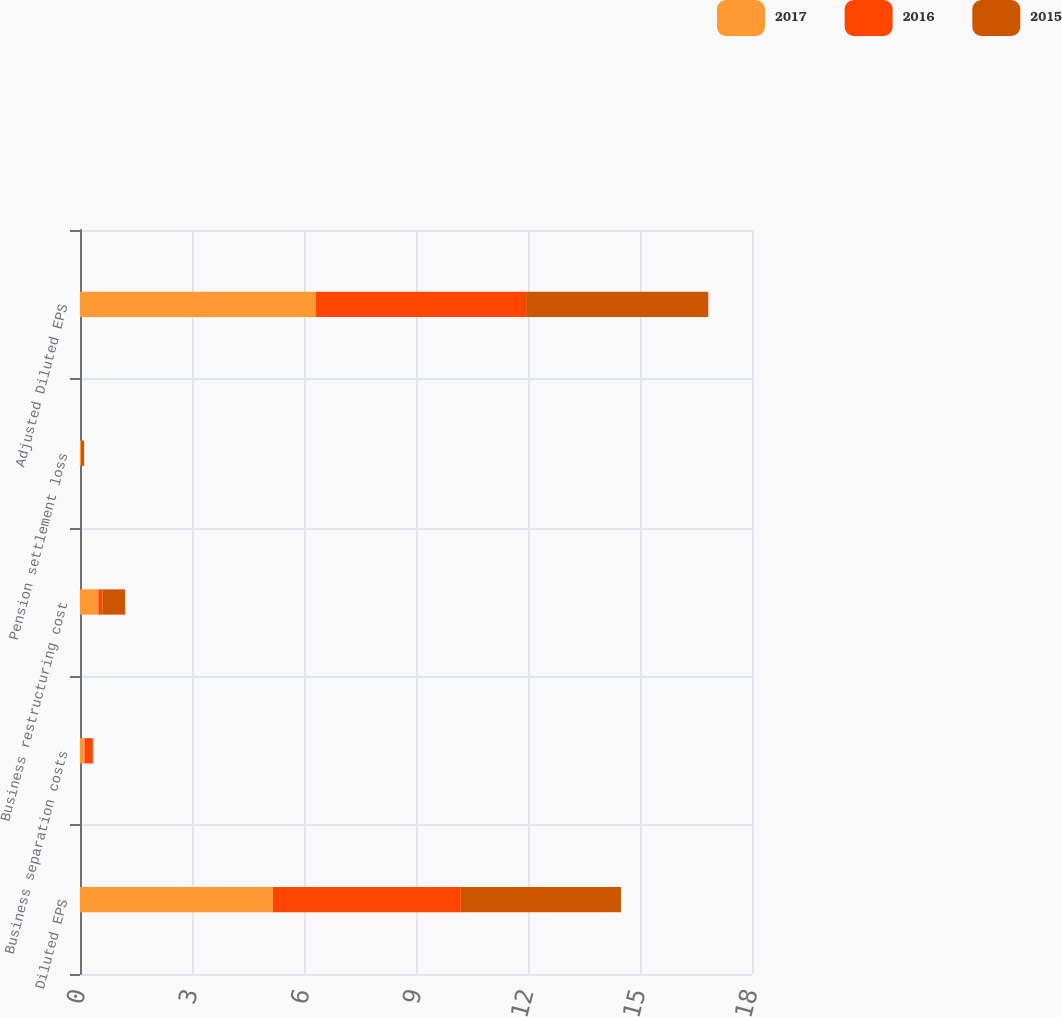<chart> <loc_0><loc_0><loc_500><loc_500><stacked_bar_chart><ecel><fcel>Diluted EPS<fcel>Business separation costs<fcel>Business restructuring cost<fcel>Pension settlement loss<fcel>Adjusted Diluted EPS<nl><fcel>2017<fcel>5.16<fcel>0.12<fcel>0.49<fcel>0.03<fcel>6.31<nl><fcel>2016<fcel>5.04<fcel>0.21<fcel>0.11<fcel>0.02<fcel>5.64<nl><fcel>2015<fcel>4.29<fcel>0.03<fcel>0.61<fcel>0.06<fcel>4.88<nl></chart> 